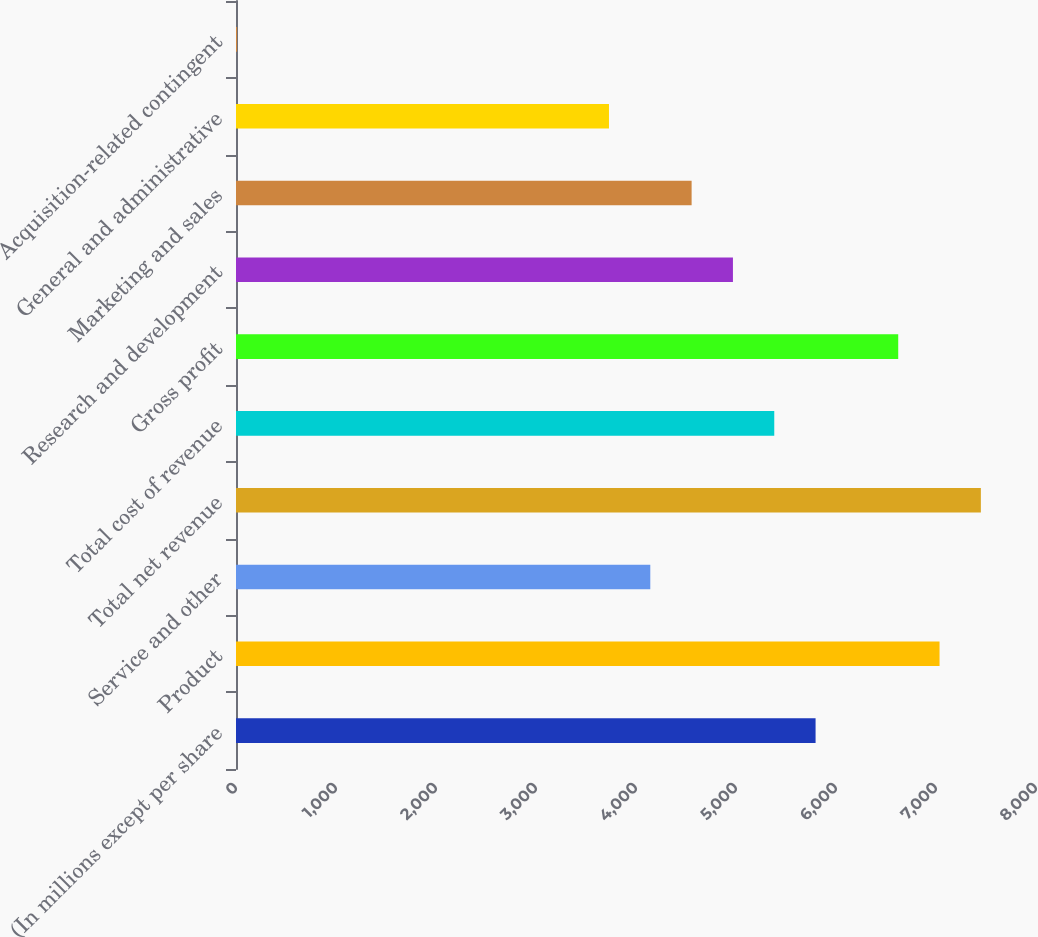Convert chart to OTSL. <chart><loc_0><loc_0><loc_500><loc_500><bar_chart><fcel>(In millions except per share<fcel>Product<fcel>Service and other<fcel>Total net revenue<fcel>Total cost of revenue<fcel>Gross profit<fcel>Research and development<fcel>Marketing and sales<fcel>General and administrative<fcel>Acquisition-related contingent<nl><fcel>5795.8<fcel>7035.4<fcel>4143<fcel>7448.6<fcel>5382.6<fcel>6622.2<fcel>4969.4<fcel>4556.2<fcel>3729.8<fcel>11<nl></chart> 